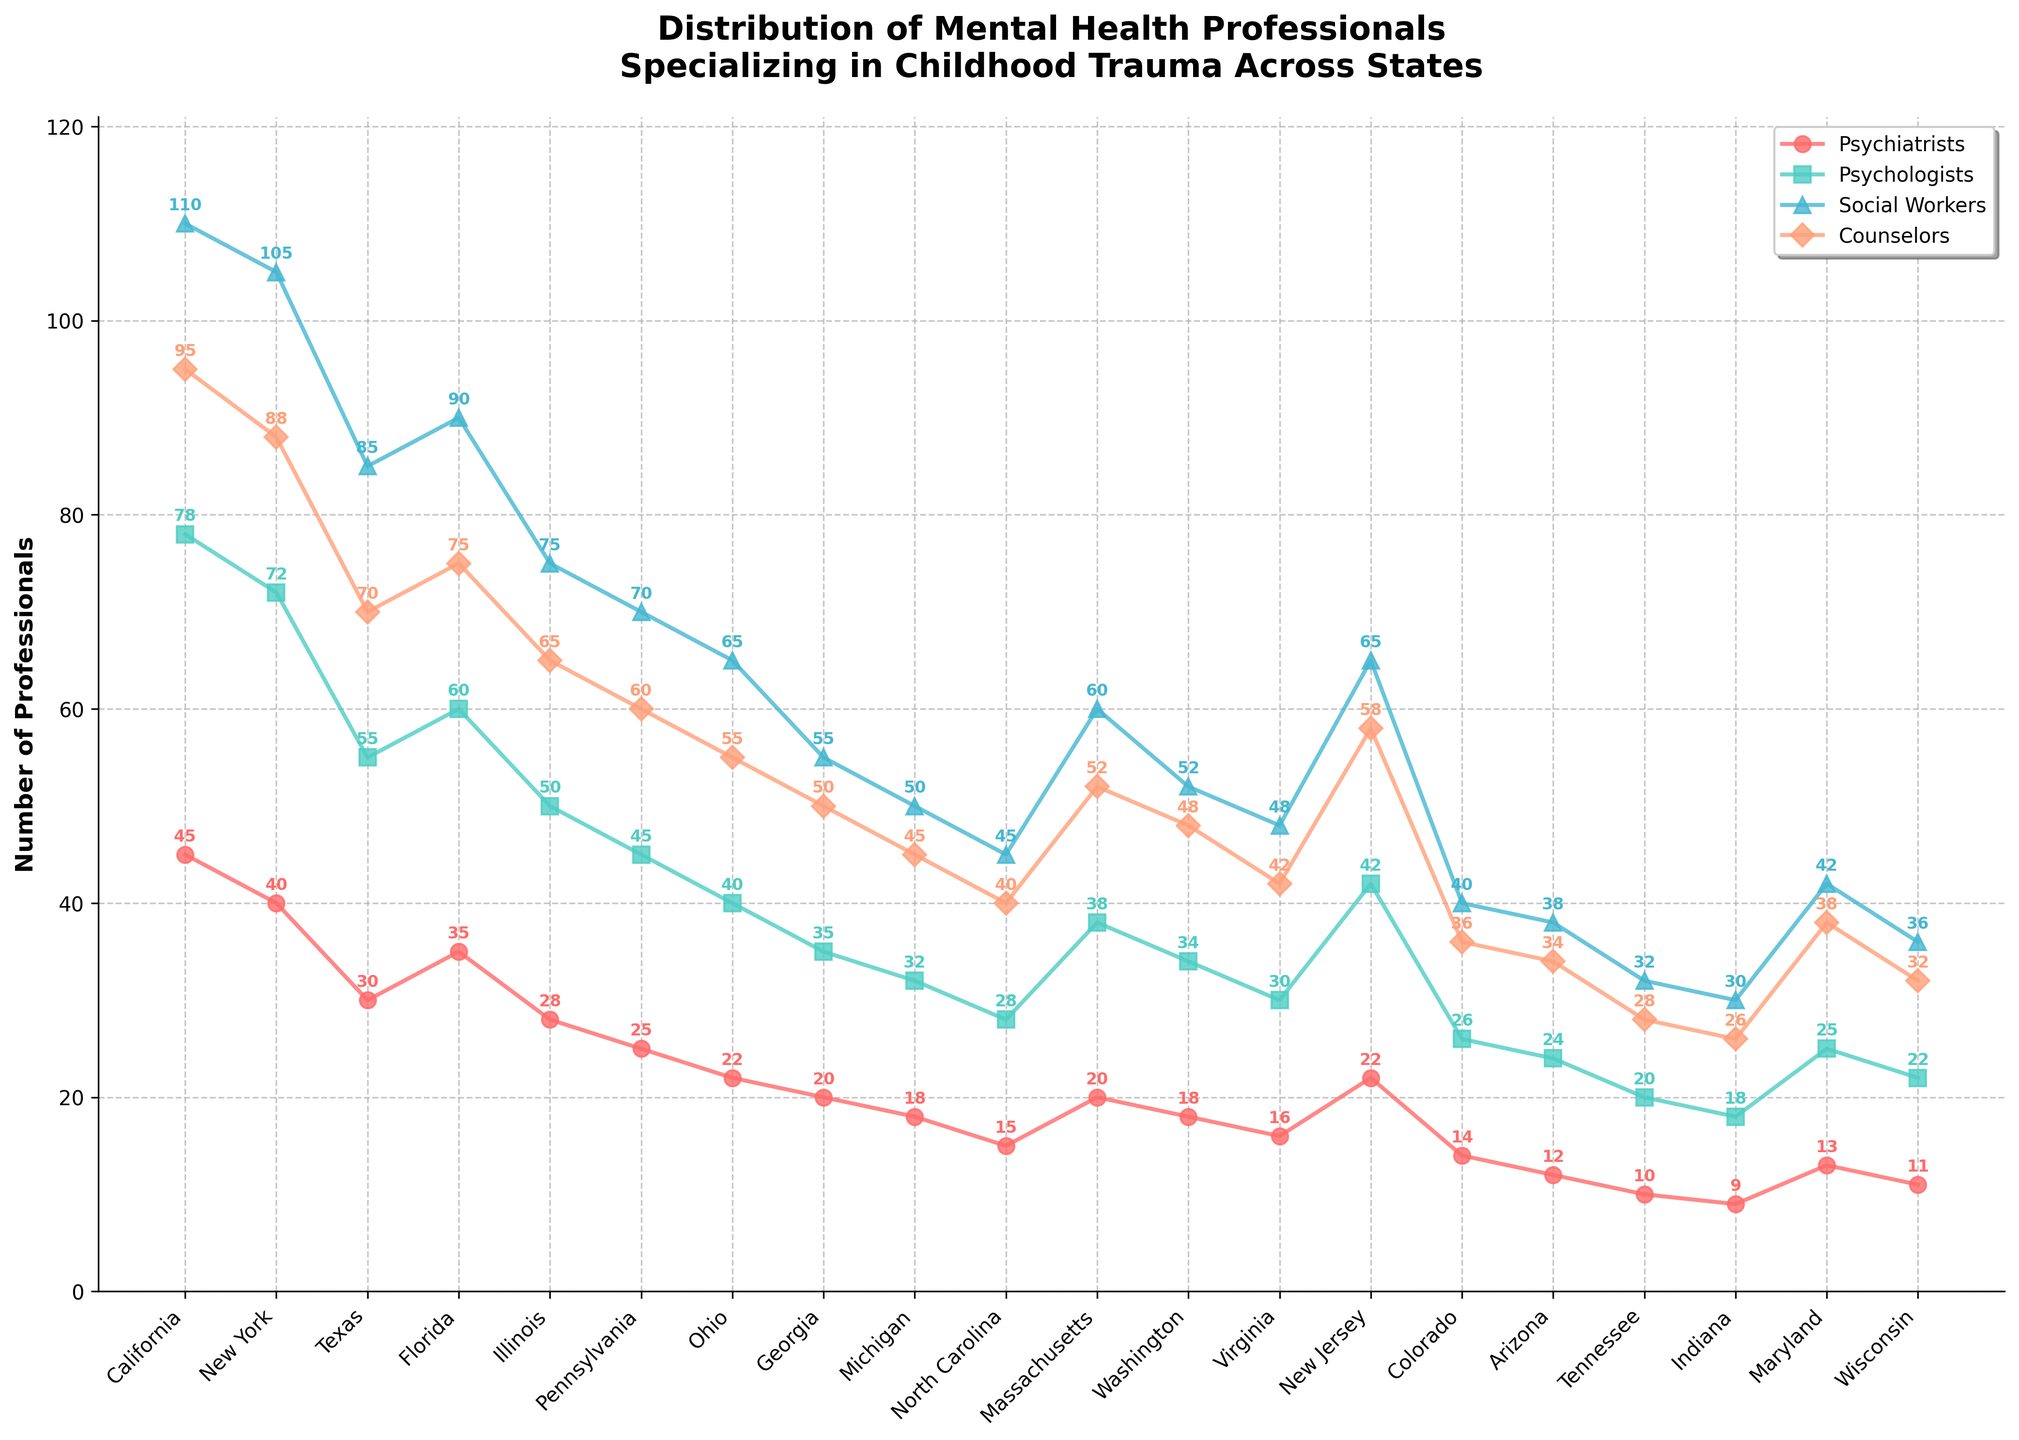What is the title of the figure? The title is typically located at the top of a plot and summarizes the main theme or subject. Here, it is present in the middle of the plot, and it reads: "Distribution of Mental Health Professionals Specializing in Childhood Trauma Across States."
Answer: Distribution of Mental Health Professionals Specializing in Childhood Trauma Across States How many states are represented in the plot? To determine the number of states represented, count the number of unique state names on the x-axis of the plot. The x-axis spans from California on the left to Wisconsin on the right.
Answer: 20 Which state has the highest number of Psychiatrists? To find the state with the most Psychiatrists, locate the line or markers representing Psychiatrists (likely color-coded and indicated in the legend) and identify the highest point on this line. The highest number of Psychiatrists is 45, which corresponds to California, as indicated by the annotation on the plot.
Answer: California What is the sum of Psychologists in California and New York? The number of Psychologists in California is 78, and in New York, it is 72. Add these two numbers together: 78 + 72.
Answer: 150 Which state has the smallest number of Social Workers, and how many are there? Identify the line or markers representing Social Workers on the plot (indicated in the legend), and find the lowest point. The smallest number of Social Workers is 30, located in Indiana, as indicated by the annotation on the plot.
Answer: Indiana, 30 Compare the number of Counselors in Florida to the number in Ohio. Which state has more, and by how much? Locate the number of Counselors in Florida (75) and Ohio (55) on the plot. Subtract the smaller number from the larger number to find the difference: 75 - 55. Florida has 20 more Counselors than Ohio.
Answer: Florida, 20 What is the average number of Psychologists across all states? Add the number of Psychologists across all states and divide by the total number of states (20). The sum of Psychologists is 756. Thus, 756 / 20 = 37.8.
Answer: 37.8 Which mental health professional group in Washington has the highest count? Look at the counts for all professional groups in Washington (Psychiatrists: 18, Psychologists: 34, Social Workers: 52, Counselors: 48). The group with the highest count is Social Workers with 52.
Answer: Social Workers How does the number of Social Workers in Georgia compare to the number in Massachusetts? Locate the count for Social Workers in Georgia (55) and Massachusetts (60). Since 55 is less than 60, Massachusetts has more Social Workers compared to Georgia.
Answer: Massachusetts What is the total number of Counselors in the top three states with the most Counselors? Identify the top three states with the highest number of Counselors (California: 95, New York: 88, Florida: 75). Sum these counts together: 95 + 88 + 75 = 258.
Answer: 258 